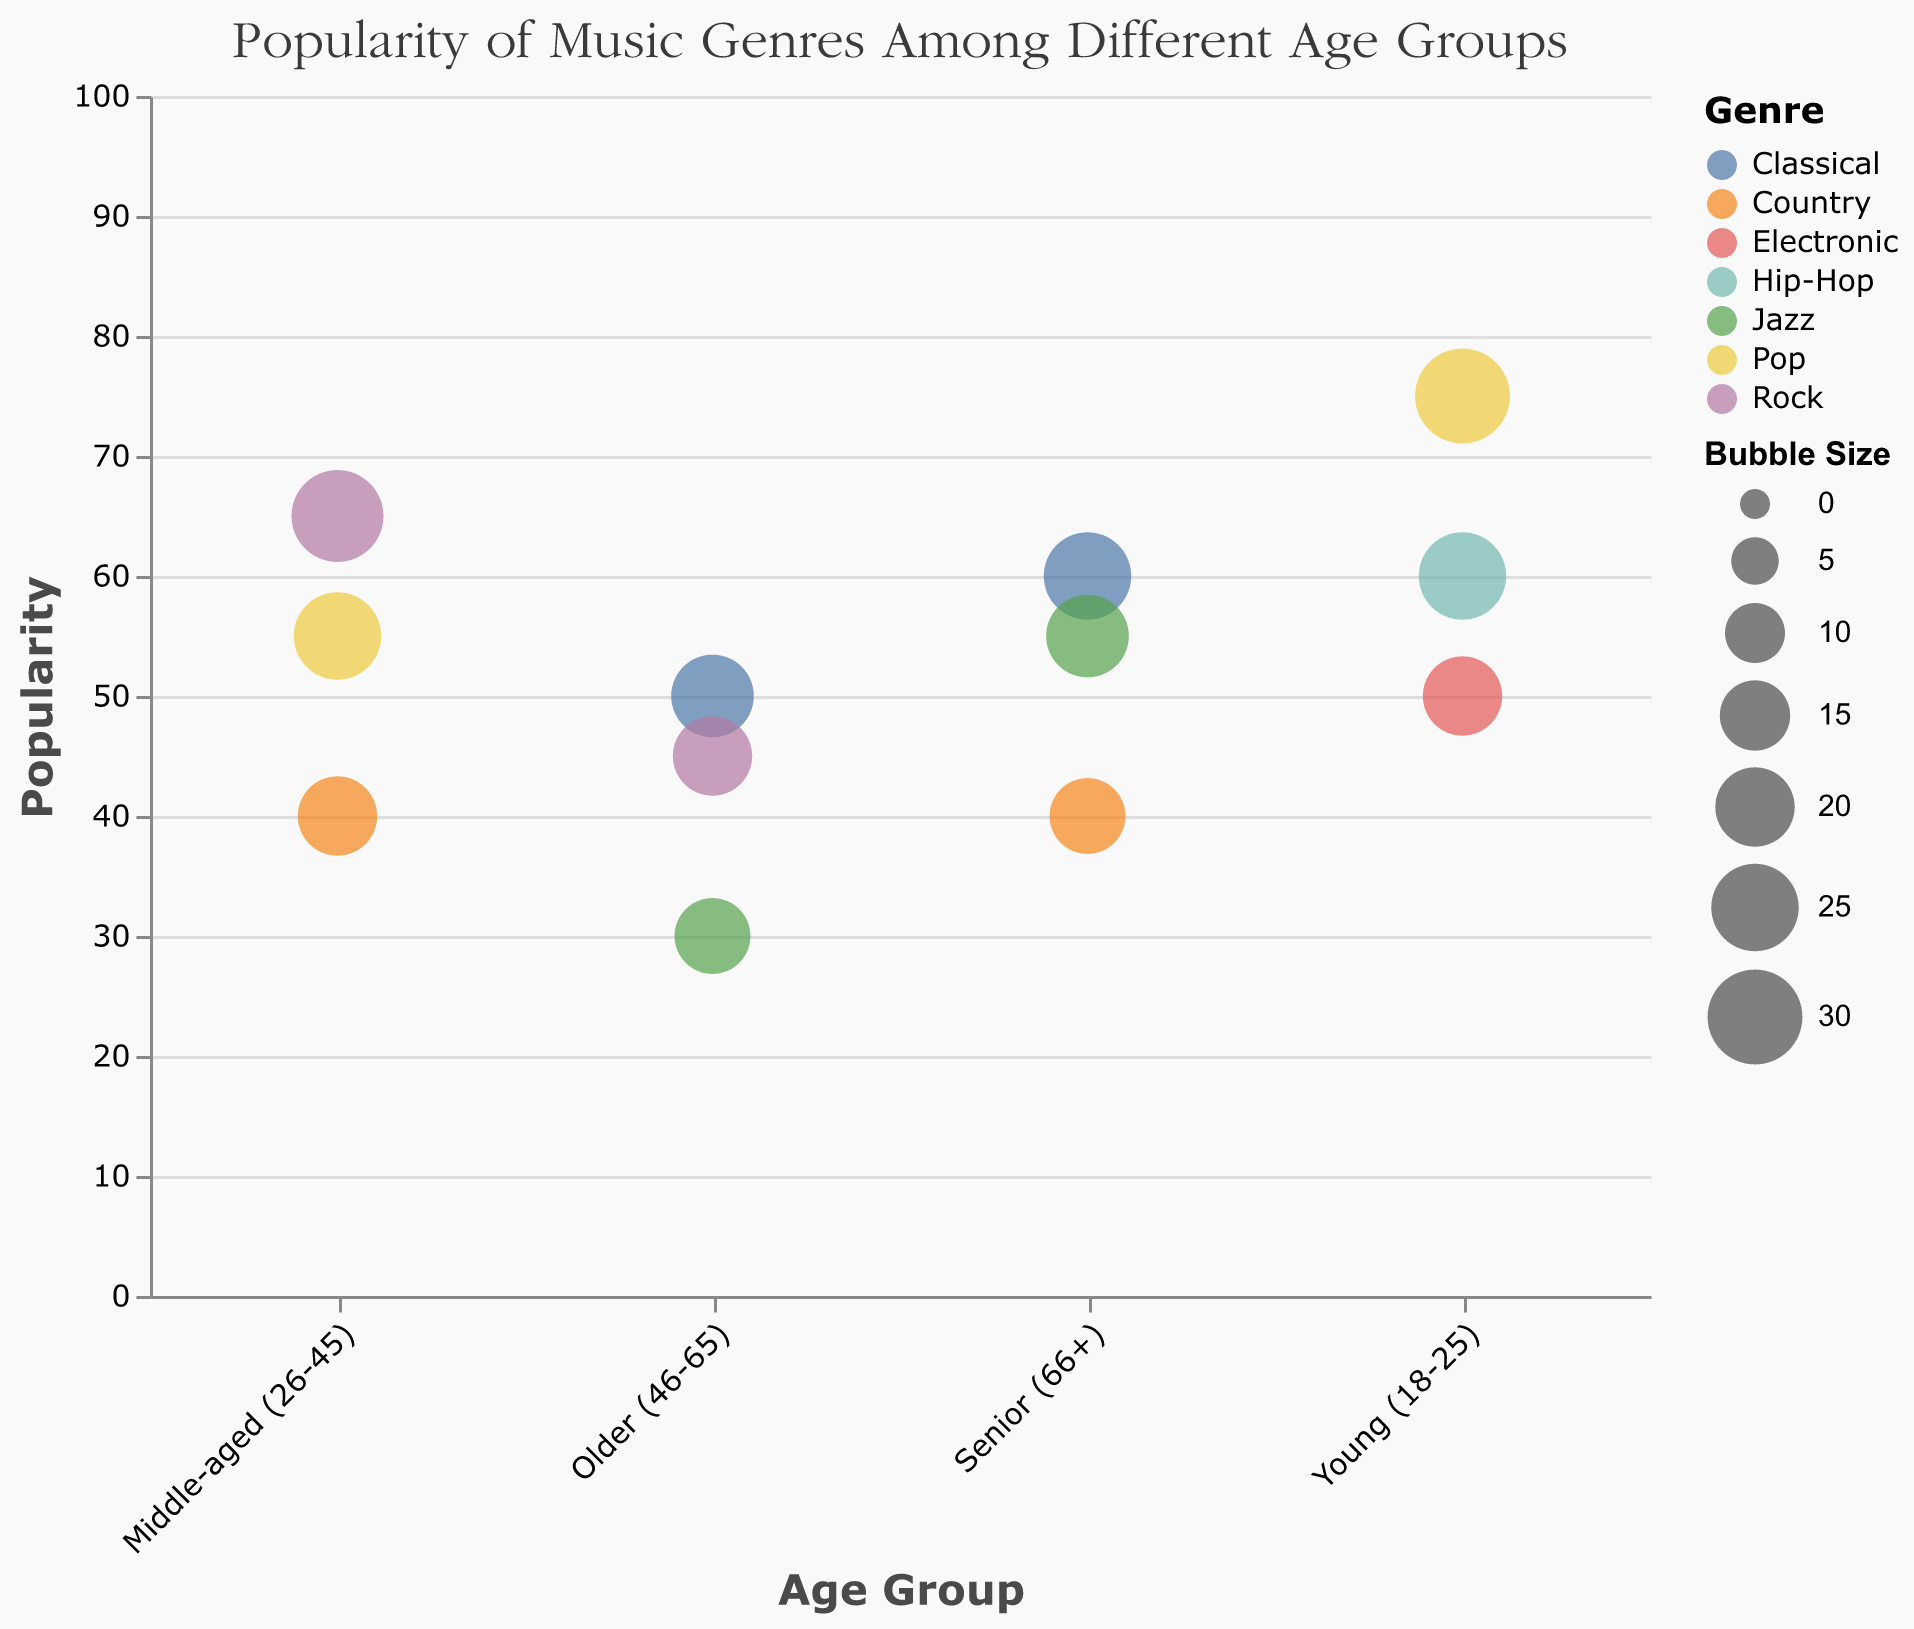Which age group has the highest popularity score for Pop music? Look for the bubble representing Pop music and then find the one with the highest y-axis (Popularity) value. The Young (18-25) age group has a Pop popularity score of 75, which is the highest.
Answer: Young (18-25) Between Middle-aged (26-45) and Senior (66+), which group has a more popular Rock genre? Compare the Popularity values of Rock music for both groups. Middle-aged (26-45) has a popularity score of 65, while Senior (66+) does not have Rock as a genre listed. Thus, Middle-aged has the more popular Rock genre.
Answer: Middle-aged (26-45) What is the total popularity score for Classical music across all age groups? Sum the Popularity scores of Classical music for all age groups: Older (46-65) and Senior (66+) have scores of 50 and 60 respectively. Thus, the total score is 50 + 60 = 110.
Answer: 110 What is the largest bubble size among all the age groups? Examine the bubble sizes listed in the data. The largest bubble size is 30, which corresponds to Pop music in the Young (18-25) age group.
Answer: 30 Are there any genres that are popular across all age groups? Look for genres that appear in all age groups. Classical music and Rock are only popular in Older (46-65) and Senior (66+). Country appears in Middle-aged (26-45) and Senior (66+). No genre is popular across all age groups.
Answer: No Which age group shows the least popularity for Jazz music? Compare the Popularity values for Jazz music among the age groups it's listed in. Jazz has scores: Older (46-65) = 30, Senior (66+) = 55. Thus, the Older (46-65) age group shows the least popularity for Jazz music.
Answer: Older (46-65) Which genre has the lowest popularity score for the Young (18-25) age group? Compare the Popularity scores for each genre in the Young (18-25) age group. Pop = 75, Hip-Hop = 60, Electronic = 50. Hence, Electronic has the lowest popularity score.
Answer: Electronic How does the popularity of Country music in the Senior (66+) group compare to the Middle-aged (26-45) group? Compare the Popularity scores of Country music in both groups. Senior (66+) = 40, Middle-aged (26-45) = 40. Both groups have equal popularity scores for Country music.
Answer: Equal Is Pop music more popular among the Young (18-25) group or the Middle-aged (26-45) group? Compare the Popularity scores for Pop music in these age groups. Young (18-25) = 75, Middle-aged (26-45) = 55. Pop music is more popular among the Young (18-25) group.
Answer: Young (18-25) Which genre has the smallest bubble size among all those listed? Compare all the Bubble Sizes in the data. Jazz in the Older (46-65) and Country in the Senior (66+) have a Bubble Size of 18, which is the smallest.
Answer: Jazz / Country 